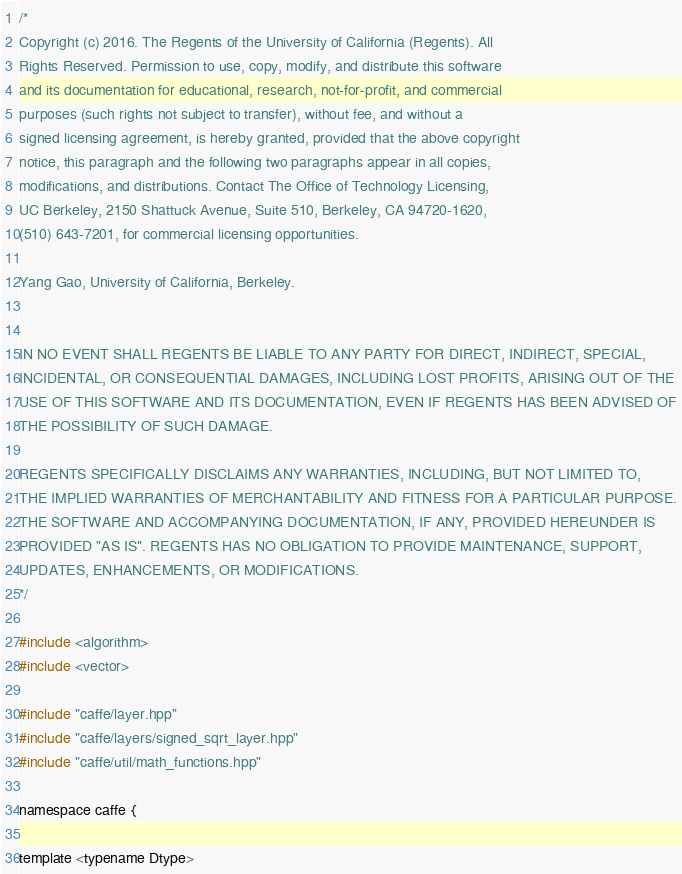Convert code to text. <code><loc_0><loc_0><loc_500><loc_500><_Cuda_>/*
Copyright (c) 2016. The Regents of the University of California (Regents). All
Rights Reserved. Permission to use, copy, modify, and distribute this software
and its documentation for educational, research, not-for-profit, and commercial
purposes (such rights not subject to transfer), without fee, and without a
signed licensing agreement, is hereby granted, provided that the above copyright
notice, this paragraph and the following two paragraphs appear in all copies,
modifications, and distributions. Contact The Office of Technology Licensing,
UC Berkeley, 2150 Shattuck Avenue, Suite 510, Berkeley, CA 94720-1620,
(510) 643-7201, for commercial licensing opportunities.

Yang Gao, University of California, Berkeley.


IN NO EVENT SHALL REGENTS BE LIABLE TO ANY PARTY FOR DIRECT, INDIRECT, SPECIAL,
INCIDENTAL, OR CONSEQUENTIAL DAMAGES, INCLUDING LOST PROFITS, ARISING OUT OF THE
USE OF THIS SOFTWARE AND ITS DOCUMENTATION, EVEN IF REGENTS HAS BEEN ADVISED OF
THE POSSIBILITY OF SUCH DAMAGE.

REGENTS SPECIFICALLY DISCLAIMS ANY WARRANTIES, INCLUDING, BUT NOT LIMITED TO,
THE IMPLIED WARRANTIES OF MERCHANTABILITY AND FITNESS FOR A PARTICULAR PURPOSE.
THE SOFTWARE AND ACCOMPANYING DOCUMENTATION, IF ANY, PROVIDED HEREUNDER IS
PROVIDED "AS IS". REGENTS HAS NO OBLIGATION TO PROVIDE MAINTENANCE, SUPPORT,
UPDATES, ENHANCEMENTS, OR MODIFICATIONS.
*/

#include <algorithm>
#include <vector>

#include "caffe/layer.hpp"
#include "caffe/layers/signed_sqrt_layer.hpp"
#include "caffe/util/math_functions.hpp"

namespace caffe {

template <typename Dtype></code> 